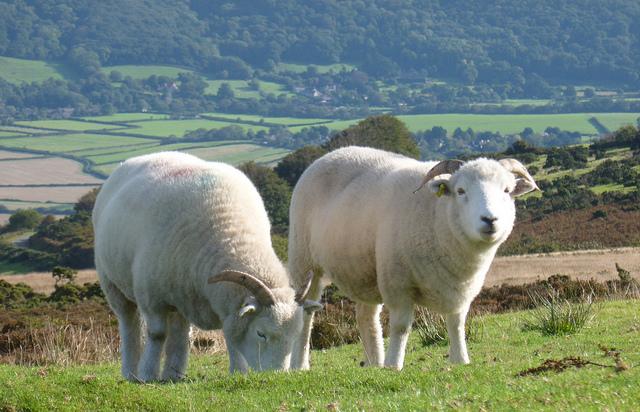How many horns are in this picture?
Concise answer only. 4. What is in the background?
Short answer required. Fields. How many have white faces?
Be succinct. 2. Do the sheep have red marks on them?
Quick response, please. No. Do these animals belong to anyone?
Answer briefly. Yes. What is in the picture?
Be succinct. Sheep. 